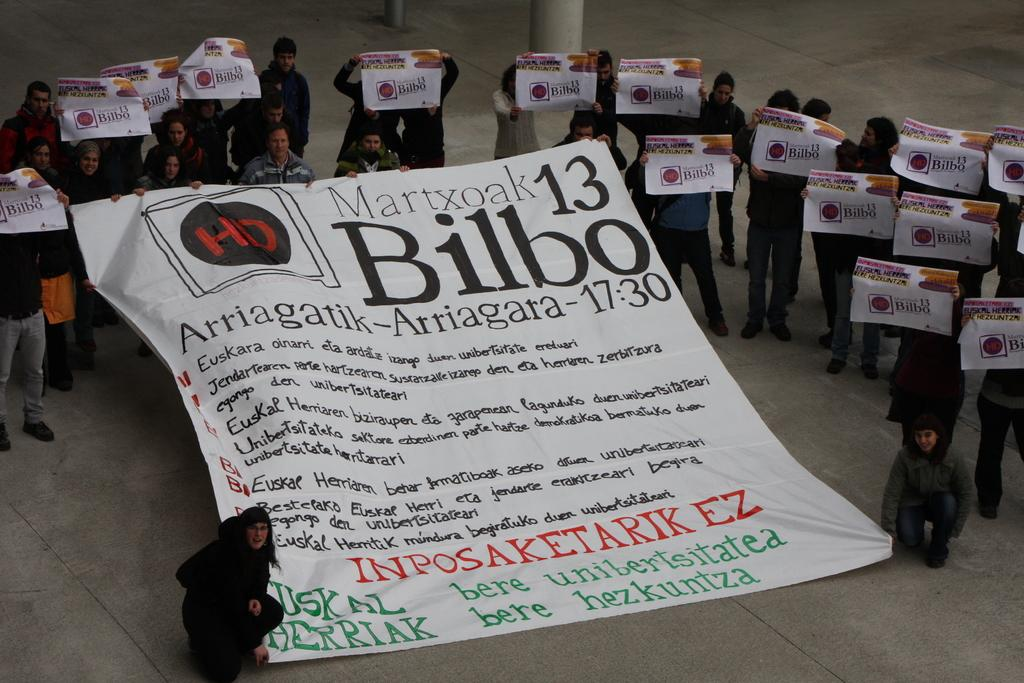Who or what is present in the image? There are people in the image. What are the people doing in the image? The people are standing in the image. What are the people holding in their hands? The people are holding posters in their hands. What type of muscle can be seen flexing on the table in the image? There is no table or muscle present in the image; it only features people holding posters. 